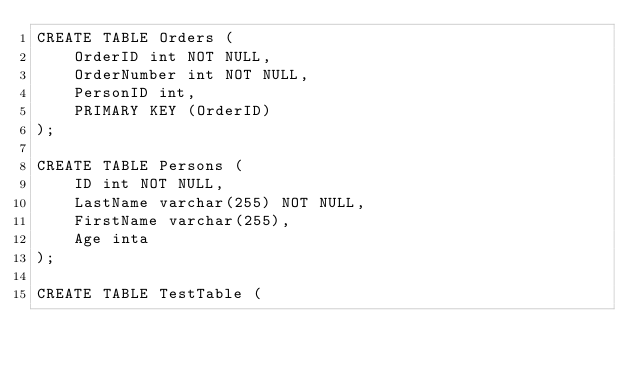<code> <loc_0><loc_0><loc_500><loc_500><_SQL_>CREATE TABLE Orders (
    OrderID int NOT NULL,
    OrderNumber int NOT NULL,
    PersonID int,
    PRIMARY KEY (OrderID)
);

CREATE TABLE Persons (
    ID int NOT NULL,
    LastName varchar(255) NOT NULL,
    FirstName varchar(255),
    Age inta
);

CREATE TABLE TestTable (</code> 